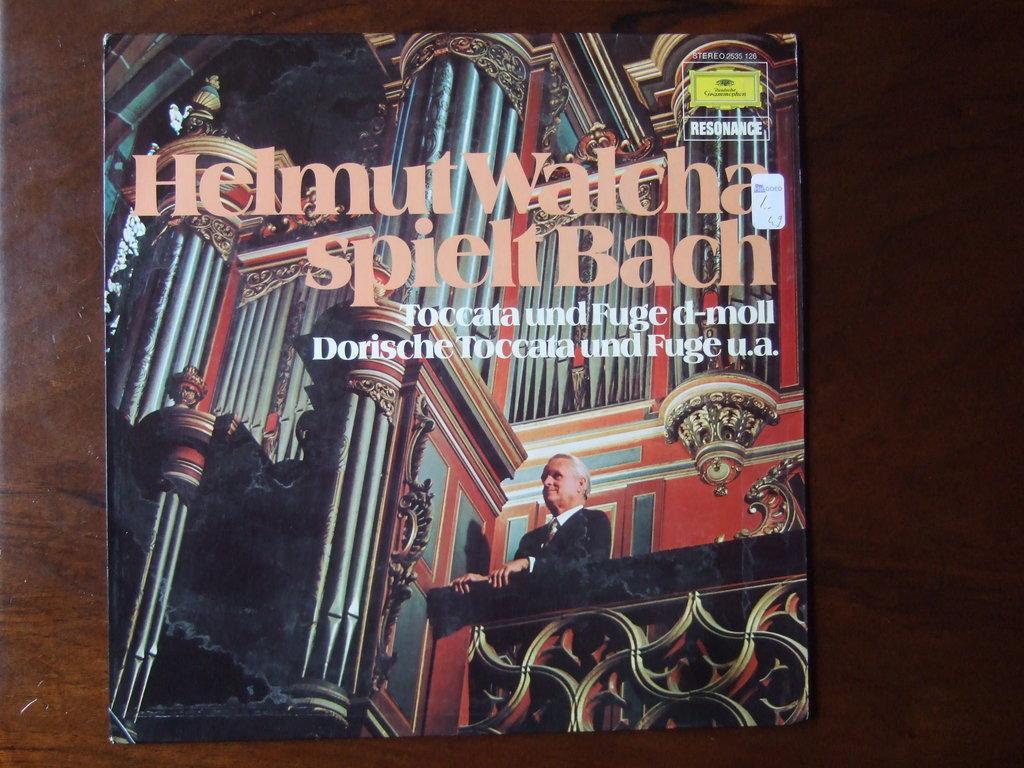Describe this image in one or two sentences. In this image in front there is a book on the table. 